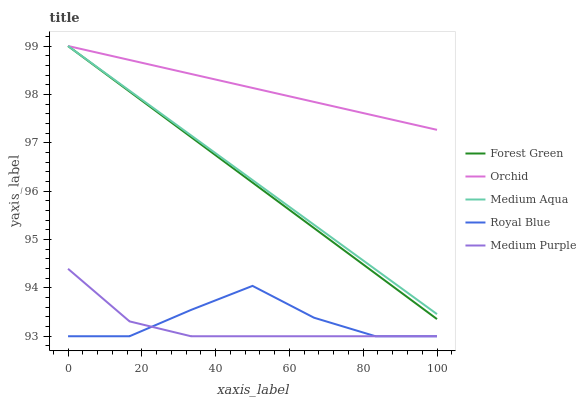Does Medium Purple have the minimum area under the curve?
Answer yes or no. Yes. Does Orchid have the maximum area under the curve?
Answer yes or no. Yes. Does Royal Blue have the minimum area under the curve?
Answer yes or no. No. Does Royal Blue have the maximum area under the curve?
Answer yes or no. No. Is Forest Green the smoothest?
Answer yes or no. Yes. Is Royal Blue the roughest?
Answer yes or no. Yes. Is Royal Blue the smoothest?
Answer yes or no. No. Is Forest Green the roughest?
Answer yes or no. No. Does Medium Purple have the lowest value?
Answer yes or no. Yes. Does Forest Green have the lowest value?
Answer yes or no. No. Does Orchid have the highest value?
Answer yes or no. Yes. Does Royal Blue have the highest value?
Answer yes or no. No. Is Medium Purple less than Orchid?
Answer yes or no. Yes. Is Orchid greater than Medium Purple?
Answer yes or no. Yes. Does Forest Green intersect Medium Aqua?
Answer yes or no. Yes. Is Forest Green less than Medium Aqua?
Answer yes or no. No. Is Forest Green greater than Medium Aqua?
Answer yes or no. No. Does Medium Purple intersect Orchid?
Answer yes or no. No. 